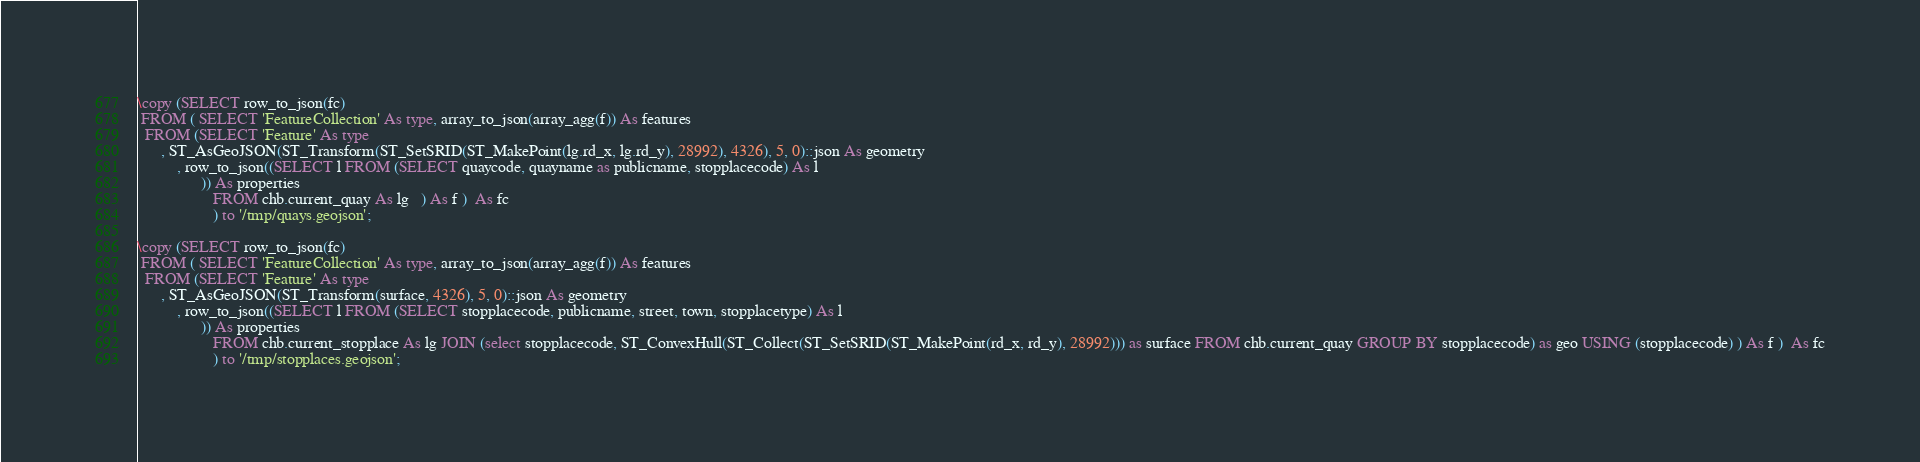<code> <loc_0><loc_0><loc_500><loc_500><_SQL_>\copy (SELECT row_to_json(fc)
 FROM ( SELECT 'FeatureCollection' As type, array_to_json(array_agg(f)) As features
  FROM (SELECT 'Feature' As type
      , ST_AsGeoJSON(ST_Transform(ST_SetSRID(ST_MakePoint(lg.rd_x, lg.rd_y), 28992), 4326), 5, 0)::json As geometry
          , row_to_json((SELECT l FROM (SELECT quaycode, quayname as publicname, stopplacecode) As l
                )) As properties
                   FROM chb.current_quay As lg   ) As f )  As fc
                   ) to '/tmp/quays.geojson';

\copy (SELECT row_to_json(fc)
 FROM ( SELECT 'FeatureCollection' As type, array_to_json(array_agg(f)) As features
  FROM (SELECT 'Feature' As type
      , ST_AsGeoJSON(ST_Transform(surface, 4326), 5, 0)::json As geometry
          , row_to_json((SELECT l FROM (SELECT stopplacecode, publicname, street, town, stopplacetype) As l
                )) As properties
                   FROM chb.current_stopplace As lg JOIN (select stopplacecode, ST_ConvexHull(ST_Collect(ST_SetSRID(ST_MakePoint(rd_x, rd_y), 28992))) as surface FROM chb.current_quay GROUP BY stopplacecode) as geo USING (stopplacecode) ) As f )  As fc
                   ) to '/tmp/stopplaces.geojson';

</code> 